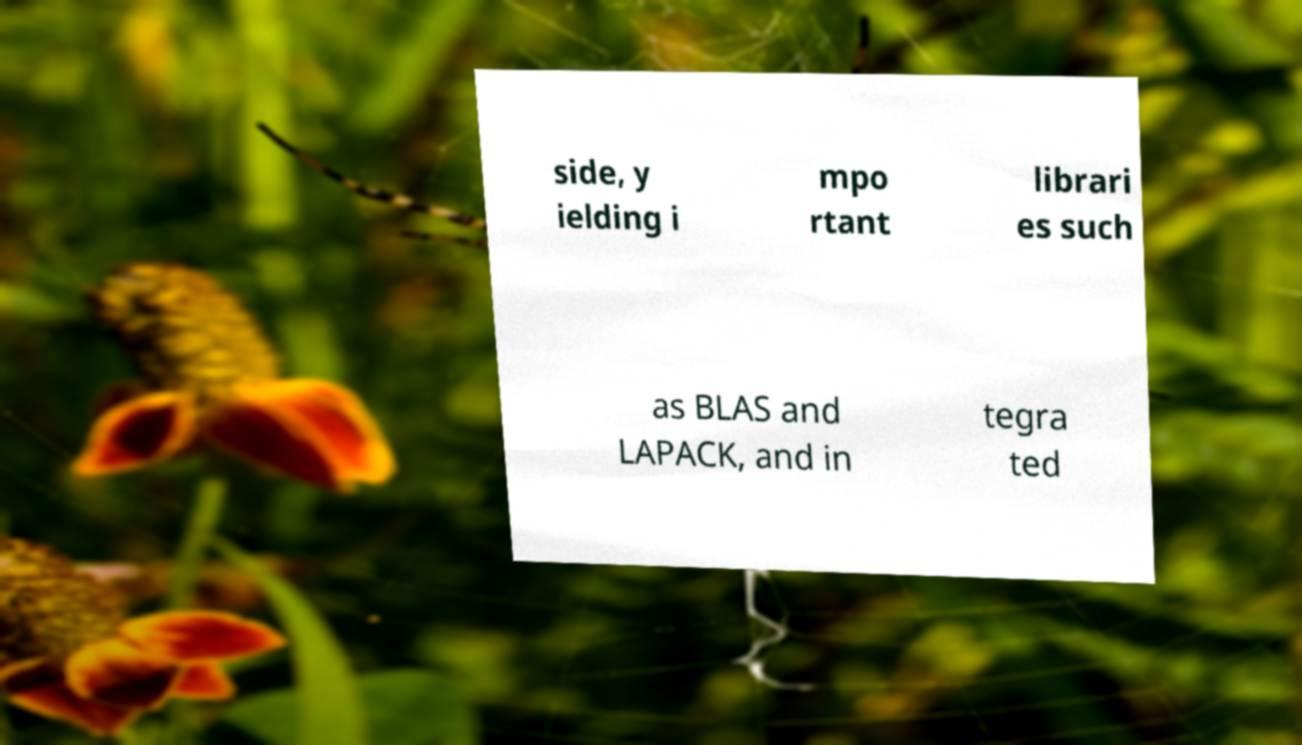For documentation purposes, I need the text within this image transcribed. Could you provide that? side, y ielding i mpo rtant librari es such as BLAS and LAPACK, and in tegra ted 